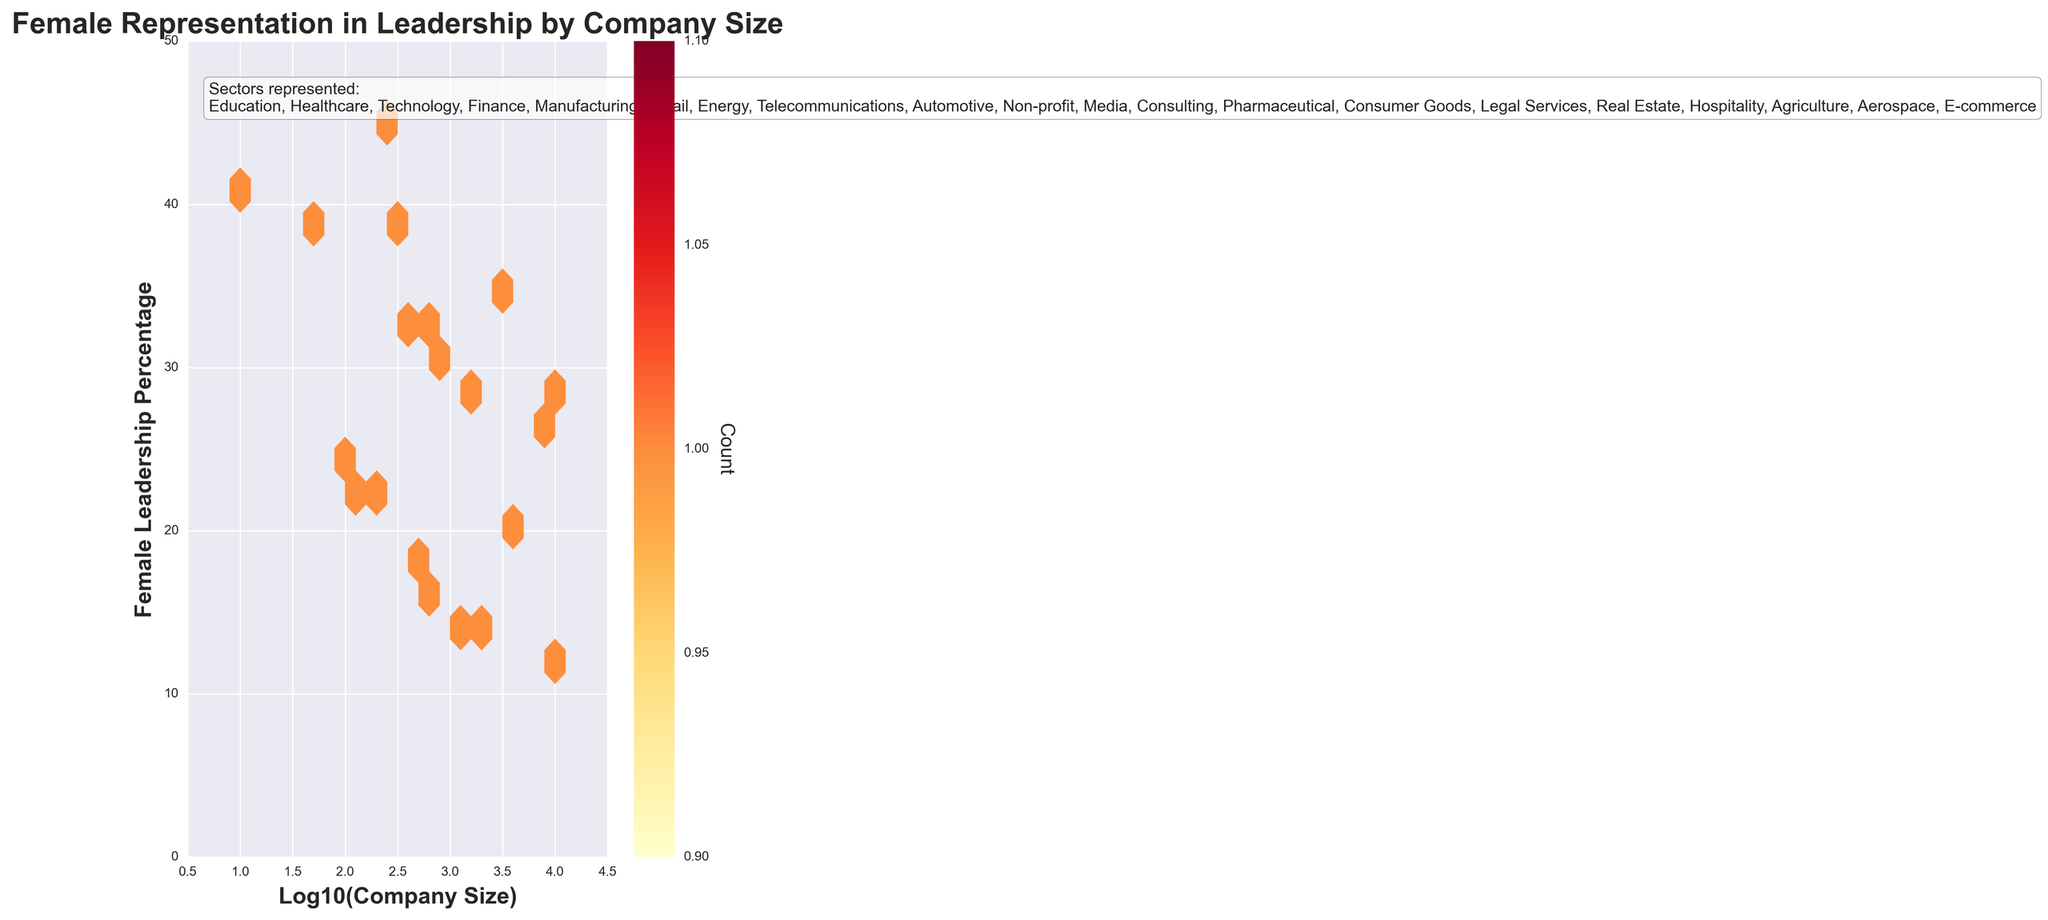What's the title of the figure? The title is displayed at the top of the figure in bold, indicating what the plot is about.
Answer: Female Representation in Leadership by Company Size What are the x-axis and y-axis representing? The labels of the axes describe what each axis represents. The x-axis is labeled 'Log10(Company Size)' and the y-axis is labeled 'Female Leadership Percentage'.
Answer: Log10(Company Size) and Female Leadership Percentage What color scheme is used in the hexbin plot? The color scheme can be identified by observing the colors in the hexagonal bins and the color bar on the right. The plot uses shades from yellow to red.
Answer: Yellow to Red How many total sectors are represented in the plot? The sectors are listed in the textbox positioned at the upper left within the plot. By counting these, we determine the total number of sectors.
Answer: 20 What's the range of 'Female Leadership Percentage' represented on the y-axis? By looking at the y-axis, we can observe the range from the minimum to the maximum value. The y-axis starts at 0 and goes up to 50.
Answer: 0 to 50 Which sector has the highest 'Female Leadership Percentage'? By reading the sectors listed in the hexbin plot, and identifying the percentage points, the 'Non-profit' sector can be determined to have the highest percentage at 45%.
Answer: Non-profit What is the hexbin plot indicating about small-sized companies compared to large-sized companies in terms of 'Female Leadership Percentage'? By comparing the distribution of data points visually in different regions of the plot, it shows that generally, smaller companies have higher percentages of female leadership compared to larger companies.
Answer: Smaller companies generally have higher percentages Between 'Media' and 'Healthcare', which sector has a higher female leadership percentage? By examining the sectors and their associated percentages, 'Media' with 33% can be compared against ‘Healthcare’ with 38%.
Answer: Healthcare has higher In which range of company size (Log10 value) do we observe the highest density of data points? By examining the color intensity in the bins, the highest density appears in regions around log10 values of 2 to 3 where x-axis and y-axis meet and are darker in color.
Answer: 2 to 3 How does the color bar help in interpreting the hexbin plot? The color bar provides a scale indicating how the density of data points increases from lighter to darker colors. This aids in interpreting regions with higher concentrations of data points.
Answer: It shows density 